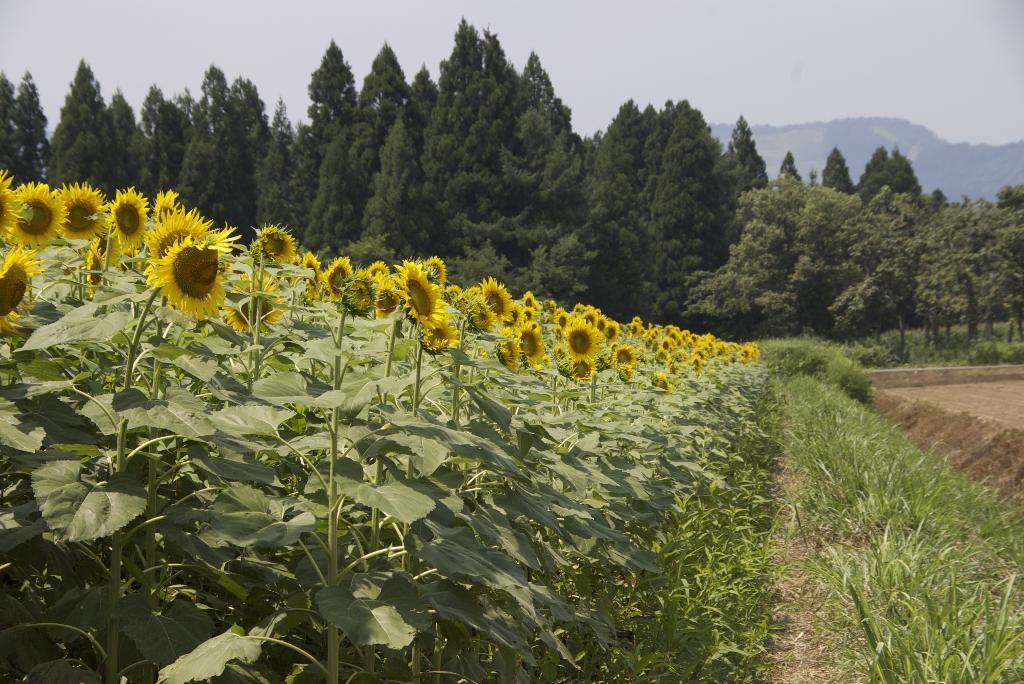What type of plants can be seen in the image? There are sunflower plants in the image. What other natural elements are present in the image? The image contains grass. What can be seen in the background of the image? There are trees with branches and leaves in the background of the image. What is visible in the sky in the image? The sky is visible in the image. What type of art is displayed on the calendar in the image? There is no calendar present in the image, so it is not possible to determine what type of art might be displayed on it. 